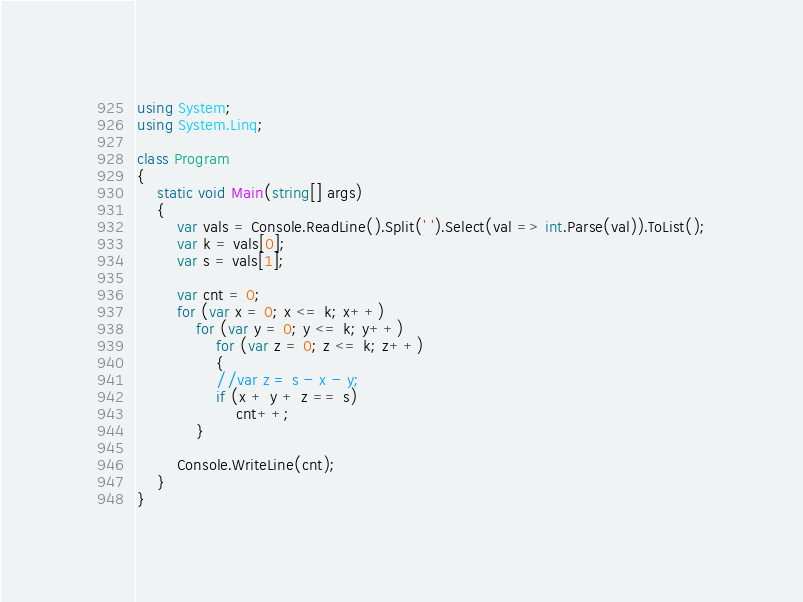<code> <loc_0><loc_0><loc_500><loc_500><_C#_>using System;
using System.Linq;

class Program
{
    static void Main(string[] args)
    {
        var vals = Console.ReadLine().Split(' ').Select(val => int.Parse(val)).ToList();
        var k = vals[0];
        var s = vals[1];

        var cnt = 0;
        for (var x = 0; x <= k; x++)
            for (var y = 0; y <= k; y++)
                for (var z = 0; z <= k; z++)
                {
                //var z = s - x - y;
                if (x + y + z == s)
                    cnt++;
            }

        Console.WriteLine(cnt);
    }
}</code> 